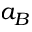Convert formula to latex. <formula><loc_0><loc_0><loc_500><loc_500>a _ { B }</formula> 